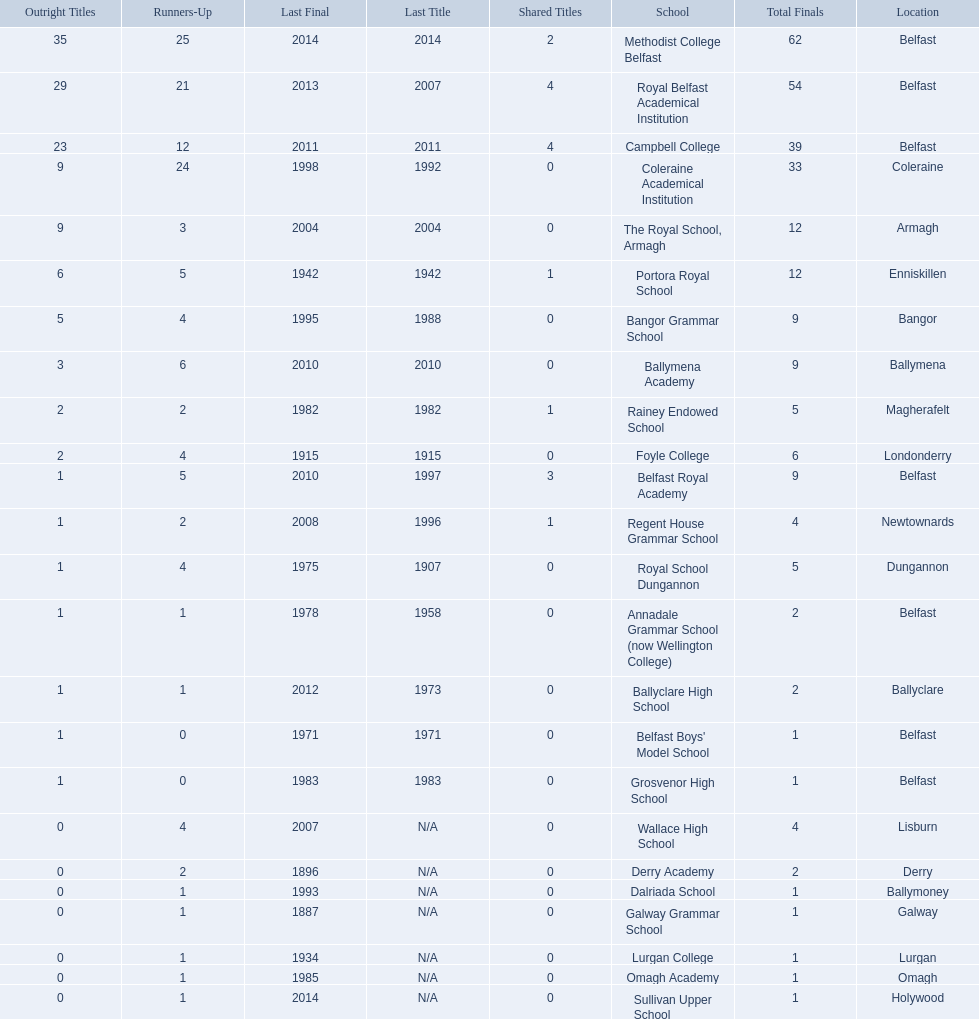What were all of the school names? Methodist College Belfast, Royal Belfast Academical Institution, Campbell College, Coleraine Academical Institution, The Royal School, Armagh, Portora Royal School, Bangor Grammar School, Ballymena Academy, Rainey Endowed School, Foyle College, Belfast Royal Academy, Regent House Grammar School, Royal School Dungannon, Annadale Grammar School (now Wellington College), Ballyclare High School, Belfast Boys' Model School, Grosvenor High School, Wallace High School, Derry Academy, Dalriada School, Galway Grammar School, Lurgan College, Omagh Academy, Sullivan Upper School. How many outright titles did they achieve? 35, 29, 23, 9, 9, 6, 5, 3, 2, 2, 1, 1, 1, 1, 1, 1, 1, 0, 0, 0, 0, 0, 0, 0. And how many did coleraine academical institution receive? 9. Which other school had the same number of outright titles? The Royal School, Armagh. 